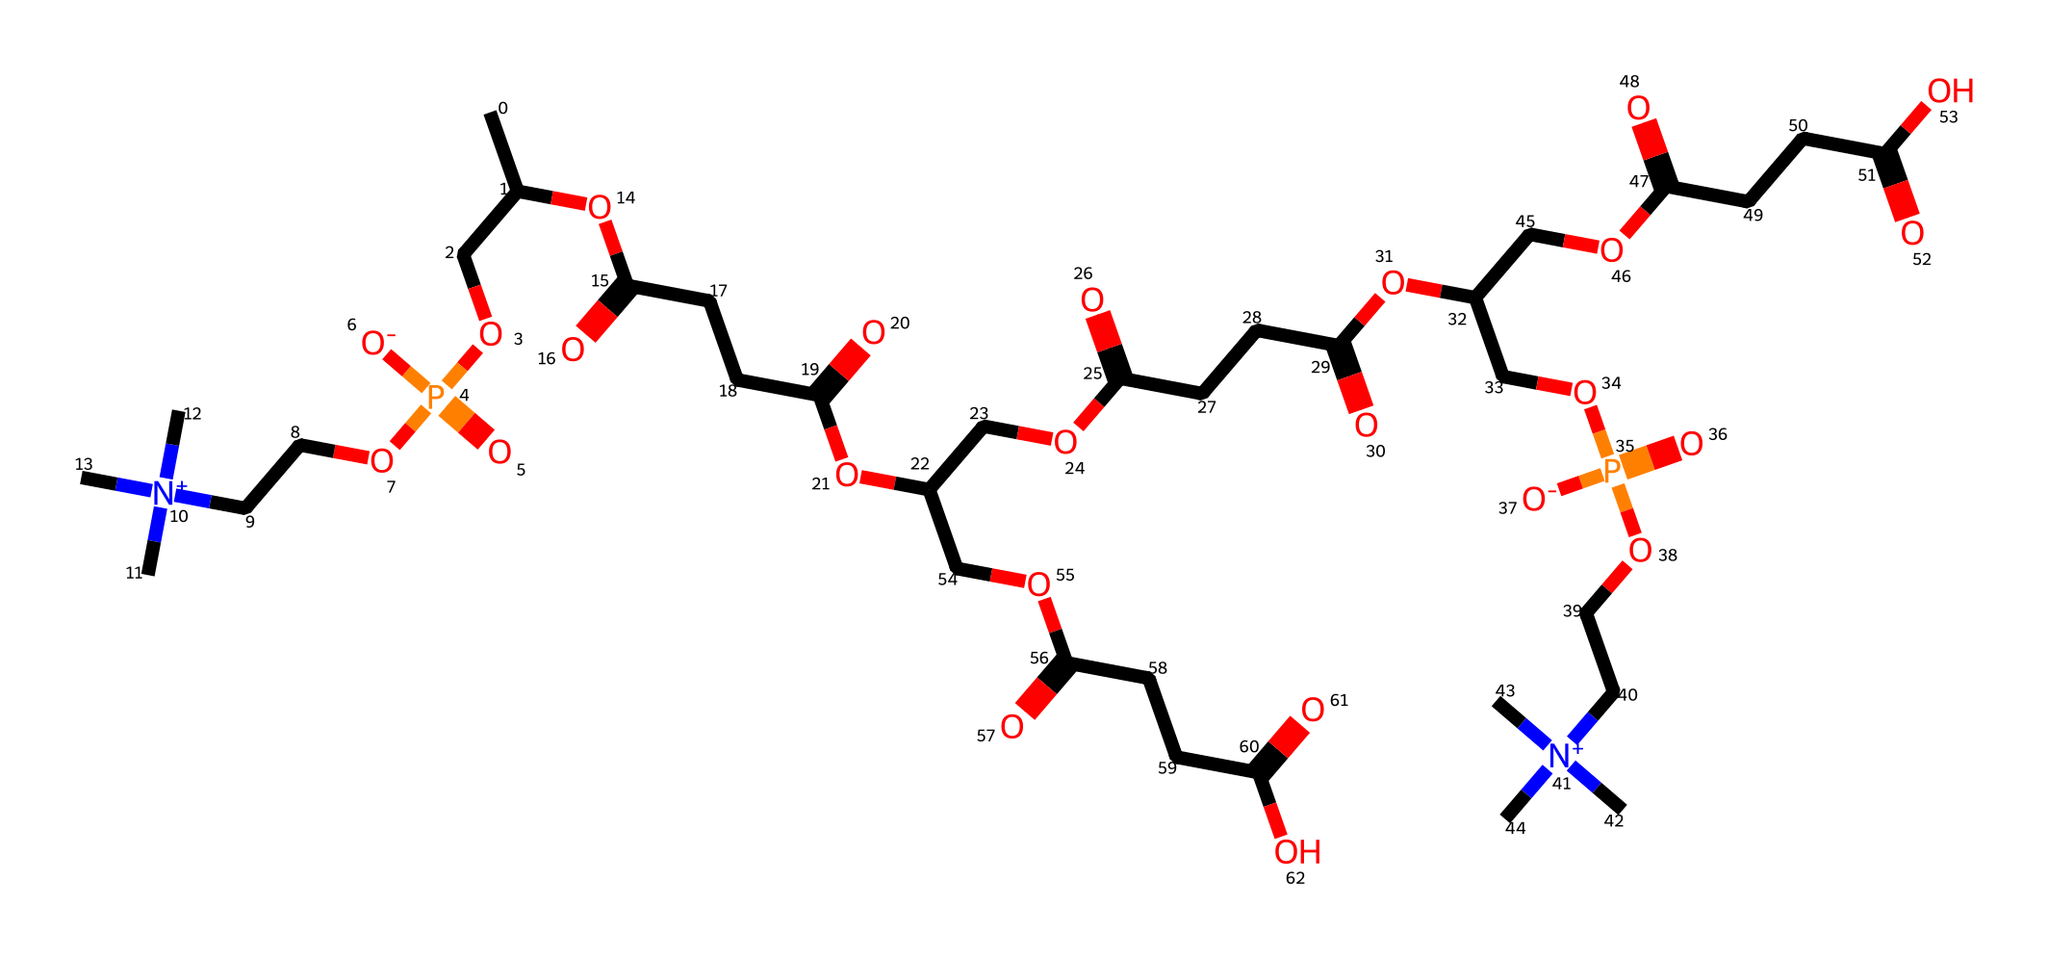What is the primary functional group present in this lecithin molecule? The presence of a phosphate group (indicated by "P(=O)") shows that this molecule has a phosphate functional group, which is characteristic of phospholipids like lecithin.
Answer: phosphate How many carbon atoms are in this structure? By counting the carbon atoms (C) within the SMILES representation, you can identify that there are 22 carbon atoms present in total within the entire molecular structure.
Answer: 22 What type of bond connects the carbon and oxygen atoms in this structure? The presence of the "C-O" representation indicates that the connection between carbon and oxygen is through a covalent bond, which is typical in organic compounds like lecithin.
Answer: covalent Does this molecule contain any nitrogen atoms? The presence of "[N+]" in the SMILES indicates that there is indeed a positively charged nitrogen within the structure, confirming the existence of nitrogen atoms.
Answer: yes What characteristic makes this molecule suitable for vegan products? The absence of any animal-derived components and the use of soy as the source indicate that the molecule is plant-based, aligning it with animal-friendly standards.
Answer: plant-based How many ester linkages are present in this structure? By identifying the "C(=O)O" segments within the SMILES, we can find that there are multiple ester linkages present, leading us to conclude that there are 4 ester linkages total in this molecule.
Answer: 4 